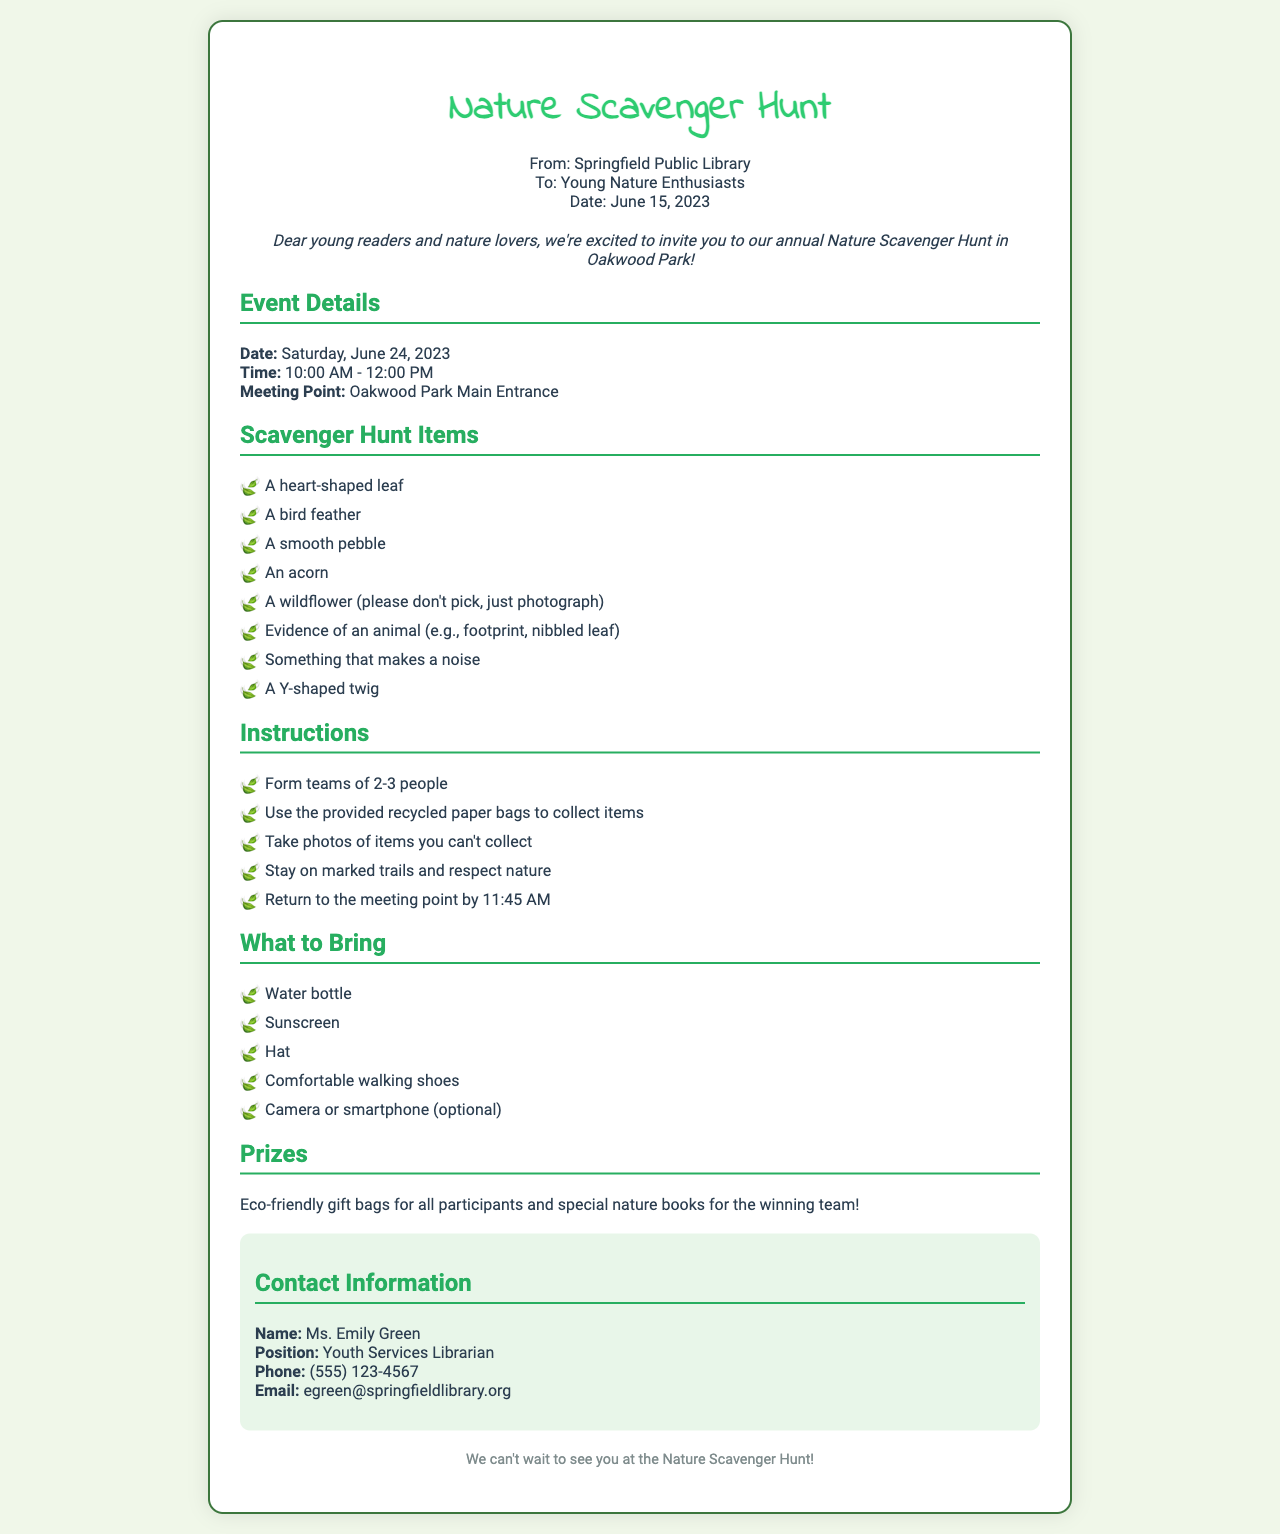What is the name of the event? The event is called "Nature Scavenger Hunt," as stated in the document title.
Answer: Nature Scavenger Hunt When is the scavenger hunt taking place? The date of the scavenger hunt is clearly mentioned in the event details section.
Answer: June 24, 2023 What time does the event start? The starting time of the event is provided in the event details section.
Answer: 10:00 AM How many people should be in each team? The instructions for forming teams specify the number of people allowed in each team.
Answer: 2-3 people What should participants bring for hydration? The list of items to bring mentions a specific item for keeping hydrated.
Answer: Water bottle What is one of the prizes for the winning team? The prizes section outlines the rewards for participants, including a specific type of book.
Answer: Nature books What type of items should not be collected? The scavenger hunt items indicate a certain item type that should be photographed instead of collected.
Answer: Wildflower Who is the contact person for the event? The contact information section provides the name of the person to reach out to regarding the event.
Answer: Ms. Emily Green What is the meeting point for the scavenger hunt? The meeting point is indicated in the event details section of the document.
Answer: Oakwood Park Main Entrance 